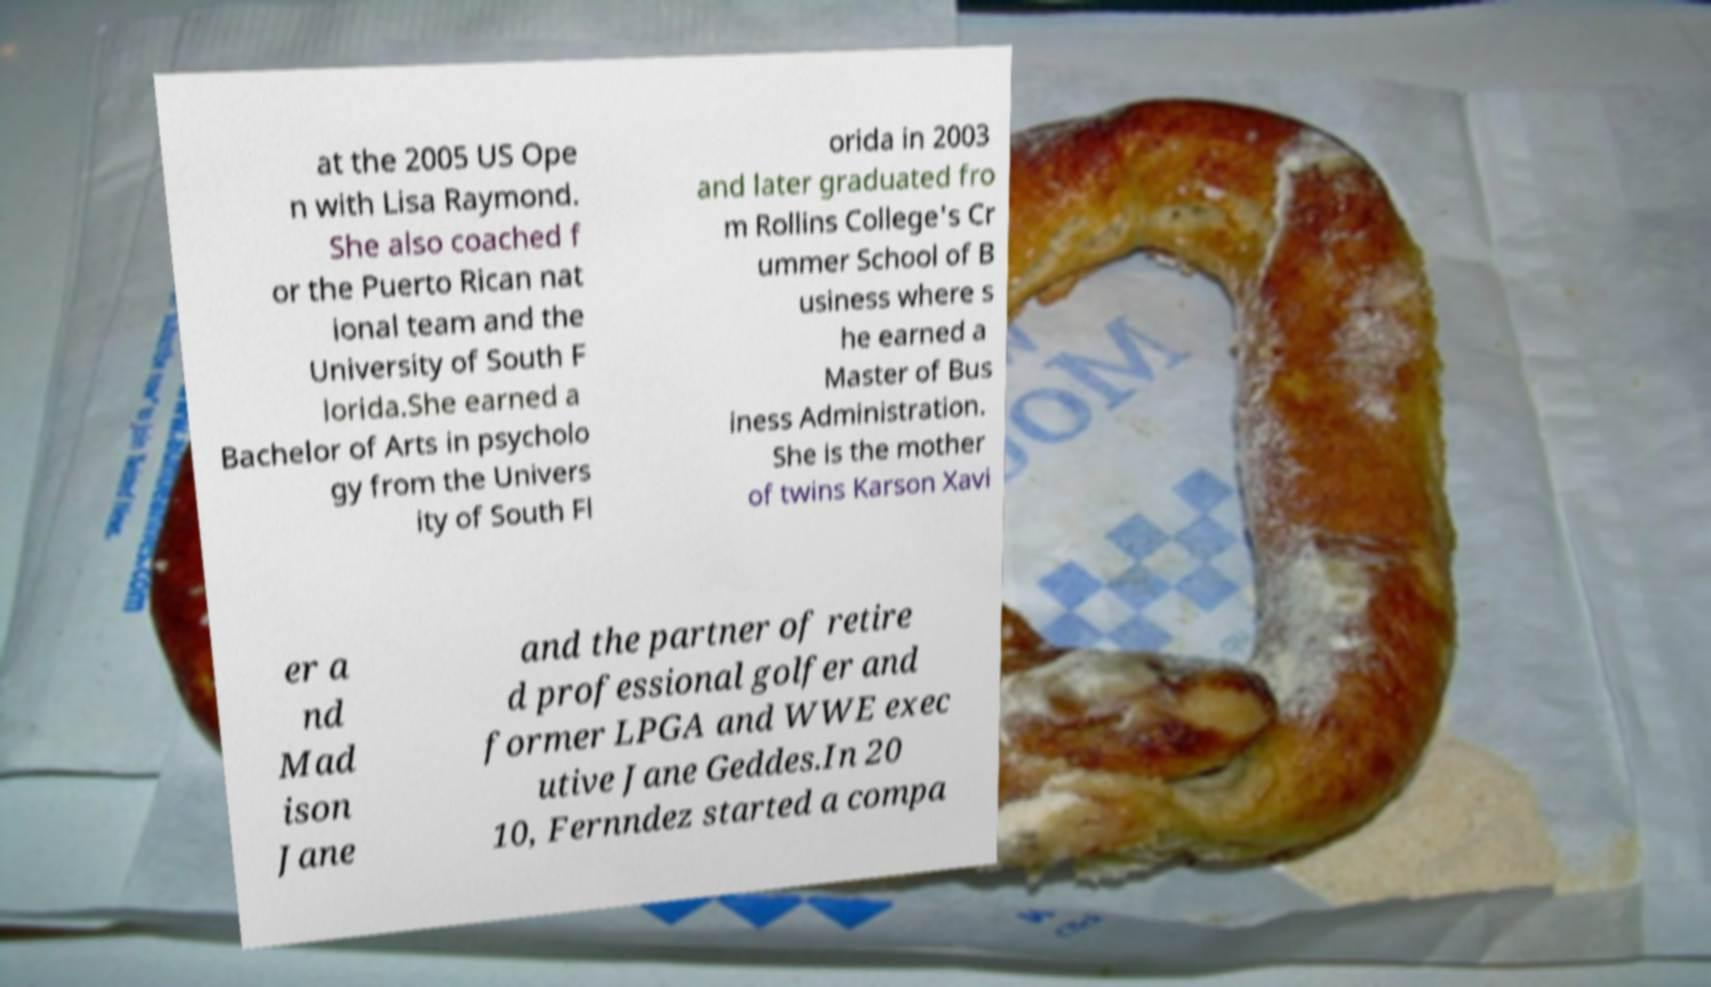Could you assist in decoding the text presented in this image and type it out clearly? at the 2005 US Ope n with Lisa Raymond. She also coached f or the Puerto Rican nat ional team and the University of South F lorida.She earned a Bachelor of Arts in psycholo gy from the Univers ity of South Fl orida in 2003 and later graduated fro m Rollins College's Cr ummer School of B usiness where s he earned a Master of Bus iness Administration. She is the mother of twins Karson Xavi er a nd Mad ison Jane and the partner of retire d professional golfer and former LPGA and WWE exec utive Jane Geddes.In 20 10, Fernndez started a compa 